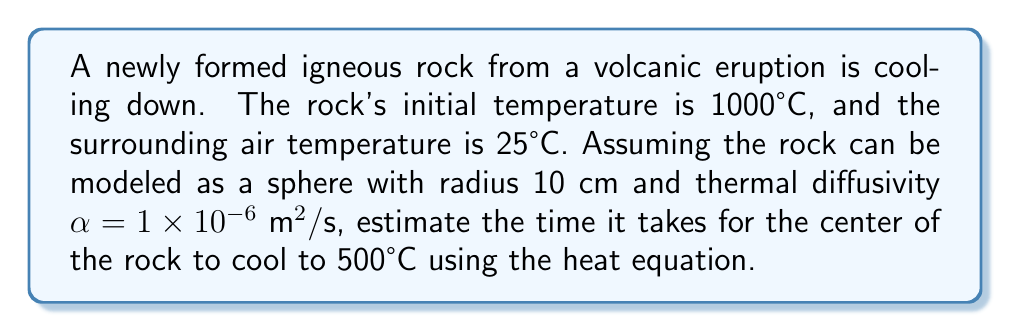Provide a solution to this math problem. To solve this problem, we'll use the heat equation for a sphere and apply the solution for cooling from an initial uniform temperature. The steps are as follows:

1) The temperature distribution in a cooling sphere is given by:

   $$T(r,t) = T_{\infty} + (T_0 - T_{\infty}) \frac{R}{r} \frac{\sin(\lambda r/R)}{\sin(\lambda)} e^{-\lambda^2 \alpha t / R^2}$$

   where $T_{\infty}$ is the ambient temperature, $T_0$ is the initial temperature, $R$ is the radius, $r$ is the radial distance from the center, $t$ is time, and $\lambda$ is the first positive root of $\tan(\lambda) = \lambda$.

2) At the center of the sphere $(r=0)$, this simplifies to:

   $$T(0,t) = T_{\infty} + (T_0 - T_{\infty}) \frac{\sin(\lambda)}{\lambda} e^{-\lambda^2 \alpha t / R^2}$$

3) We're given:
   $T_0 = 1000°C$, $T_{\infty} = 25°C$, $R = 0.1 \text{ m}$, $\alpha = 1 \times 10^{-6} \text{ m}^2/\text{s}$

4) We need to find $t$ when $T(0,t) = 500°C$. Substituting these values:

   $$500 = 25 + (1000 - 25) \frac{\sin(\lambda)}{\lambda} e^{-\lambda^2 (1 \times 10^{-6}) t / (0.1)^2}$$

5) The first positive root of $\tan(\lambda) = \lambda$ is approximately $\lambda \approx 4.4934$.

6) Substituting and solving for $t$:

   $$\frac{500 - 25}{1000 - 25} = \frac{\sin(4.4934)}{4.4934} e^{-4.4934^2 (1 \times 10^{-6}) t / (0.1)^2}$$

   $$0.4872 = 0.2172 e^{-0.002021t}$$

   $$\ln(0.4872/0.2172) = -0.002021t$$

   $$t = \frac{\ln(0.4872/0.2172)}{-0.002021} \approx 409,800 \text{ seconds}$$

7) Converting to hours:

   $$409,800 \text{ seconds} \approx 113.8 \text{ hours}$$

Thus, it takes approximately 114 hours for the center of the rock to cool to 500°C.
Answer: 114 hours 